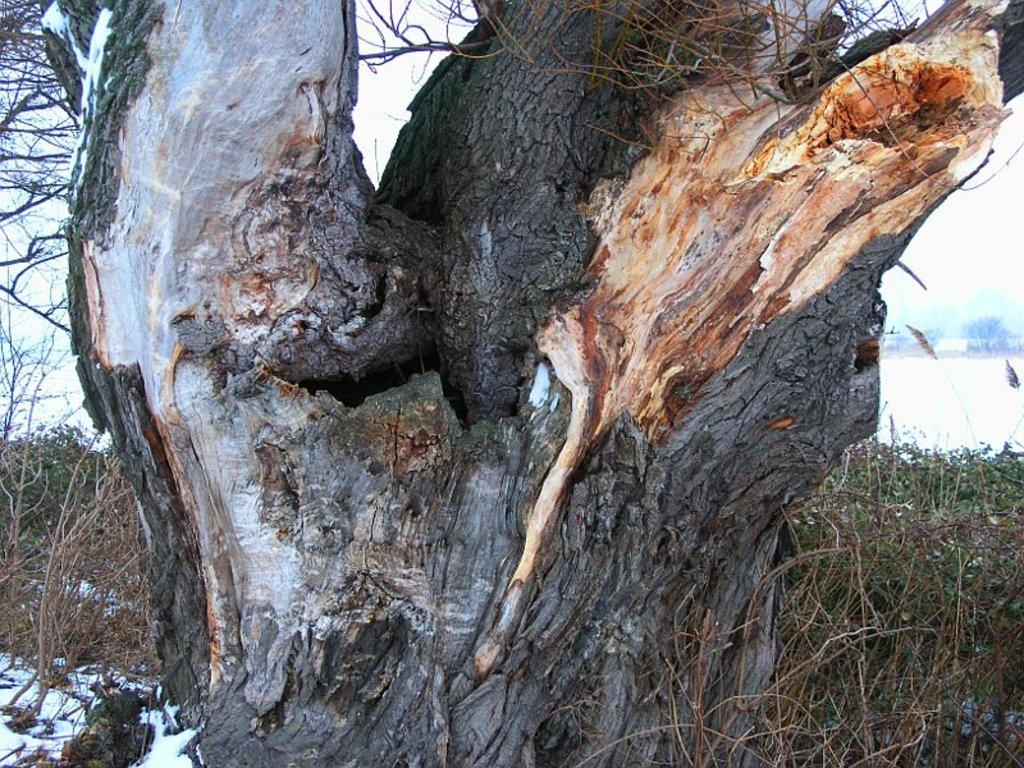What is the main feature of the image with a black color? There is a tree trunk with black color in the image. What type of vegetation can be seen at the bottom of the image? There is grass visible at the bottom of the image. What type of note is attached to the goose in the image? There is no goose or note present in the image. 